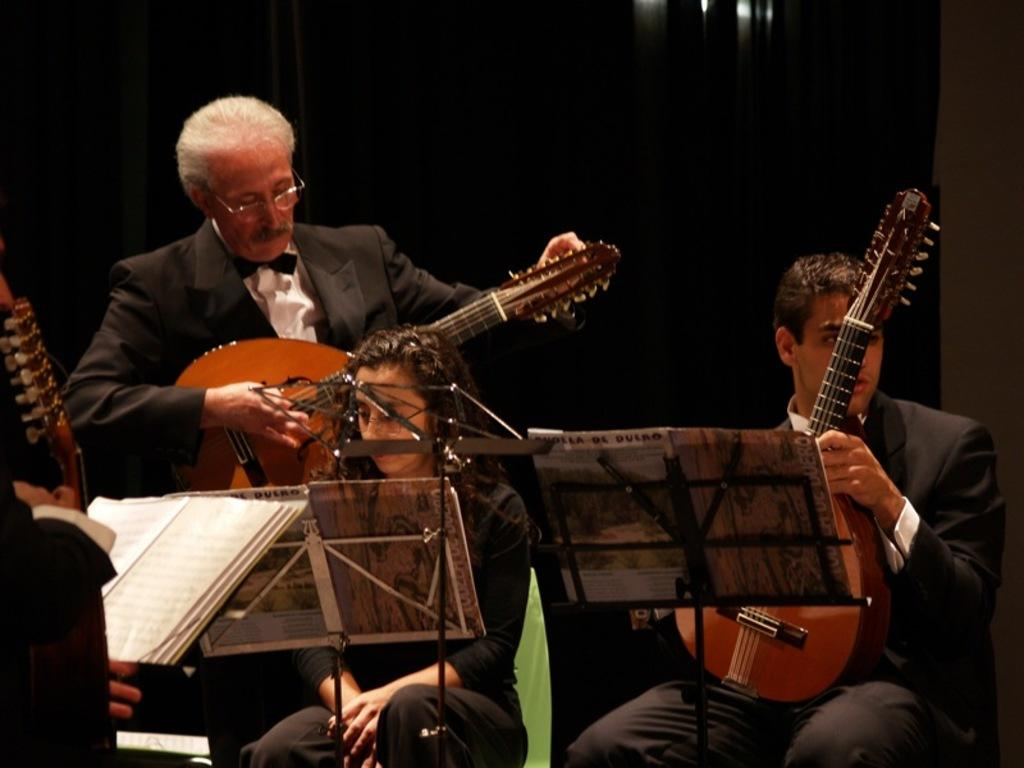Who or what can be seen in the image? There are people in the image. What are the people doing in the image? The people are playing musical instruments. What type of oil is being used to lubricate the instruments in the image? There is no mention of oil or lubrication in the image; the people are simply playing musical instruments. 